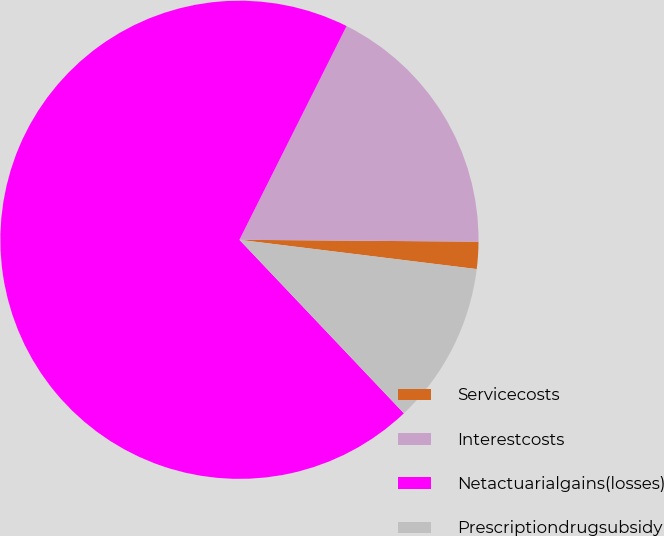Convert chart to OTSL. <chart><loc_0><loc_0><loc_500><loc_500><pie_chart><fcel>Servicecosts<fcel>Interestcosts<fcel>Netactuarialgains(losses)<fcel>Prescriptiondrugsubsidy<nl><fcel>1.83%<fcel>17.73%<fcel>69.47%<fcel>10.97%<nl></chart> 